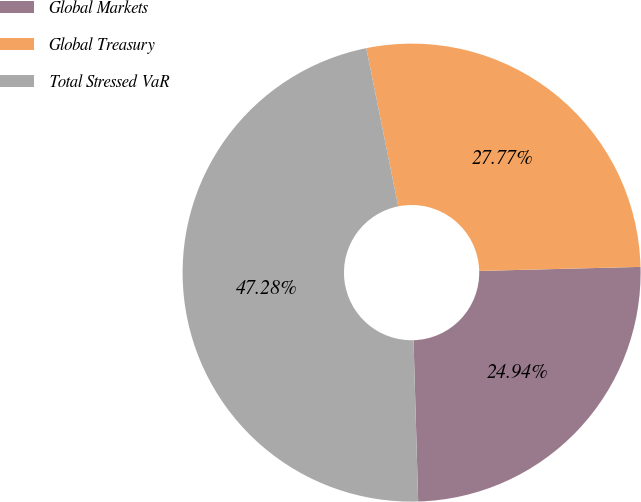Convert chart. <chart><loc_0><loc_0><loc_500><loc_500><pie_chart><fcel>Global Markets<fcel>Global Treasury<fcel>Total Stressed VaR<nl><fcel>24.94%<fcel>27.77%<fcel>47.28%<nl></chart> 